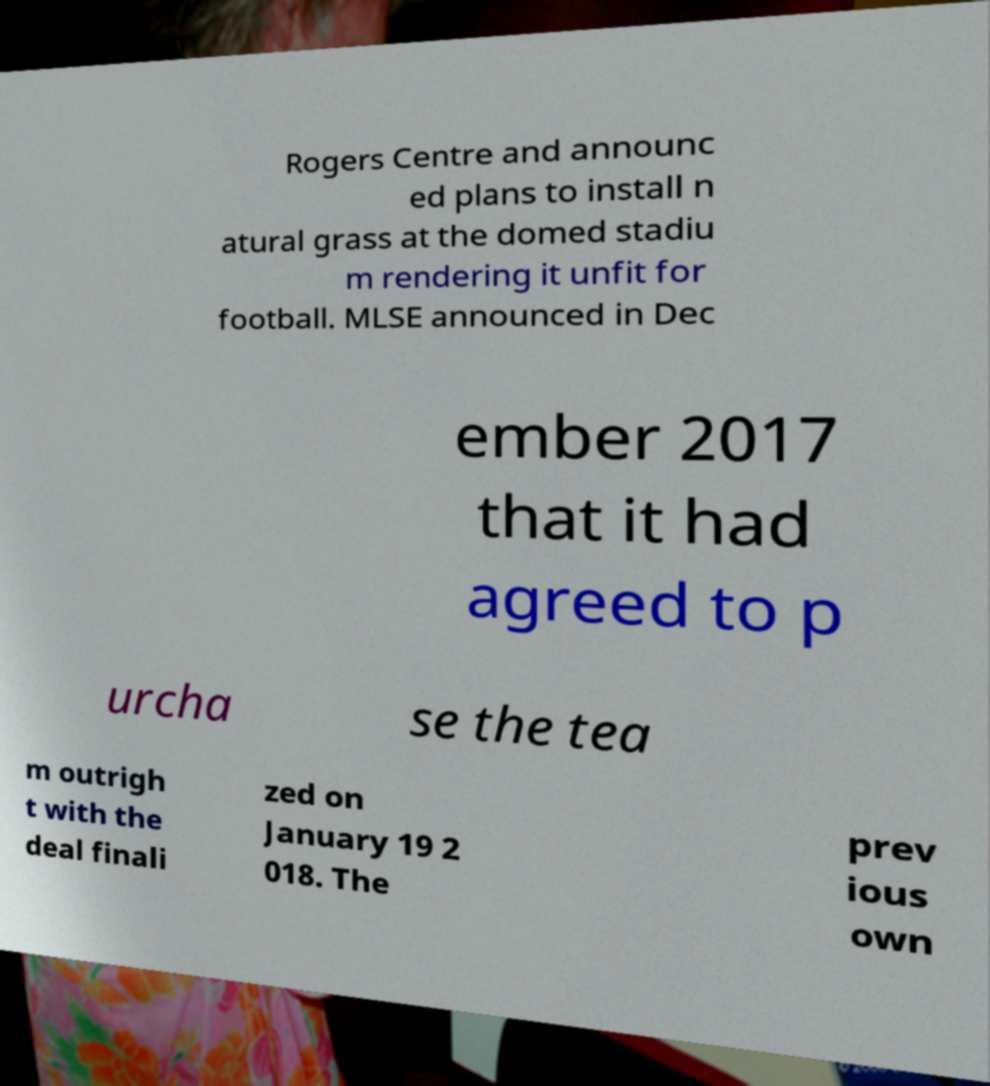Could you extract and type out the text from this image? Rogers Centre and announc ed plans to install n atural grass at the domed stadiu m rendering it unfit for football. MLSE announced in Dec ember 2017 that it had agreed to p urcha se the tea m outrigh t with the deal finali zed on January 19 2 018. The prev ious own 